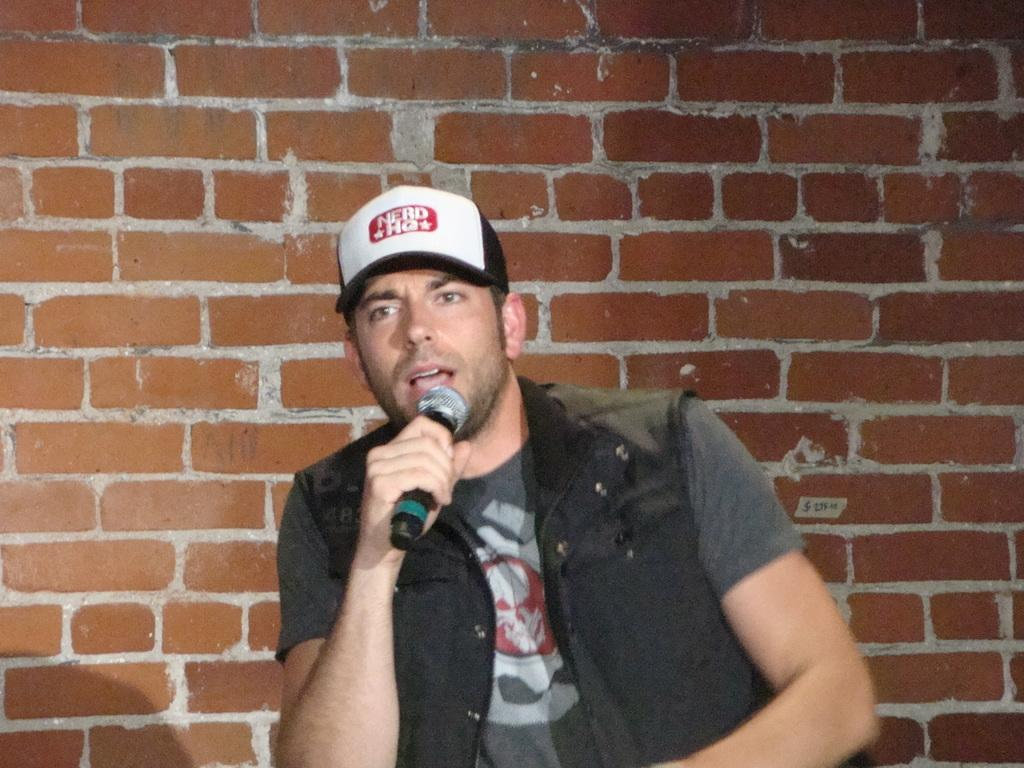What is the main subject of the image? There is a man in the image. What is the man doing in the image? The man is speaking in the image. What object is the man holding in his hand? The man is holding a microphone in his hand. What can be seen in the background of the image? There is a wall of red bricks in the background of the image. Can you tell me what type of spark the man is creating with the microphone in the image? There is no spark present in the image; the man is simply holding a microphone while speaking. Is there an argument taking place between the man and someone else in the image? There is no indication of an argument in the image; the man is simply speaking while holding a microphone. 